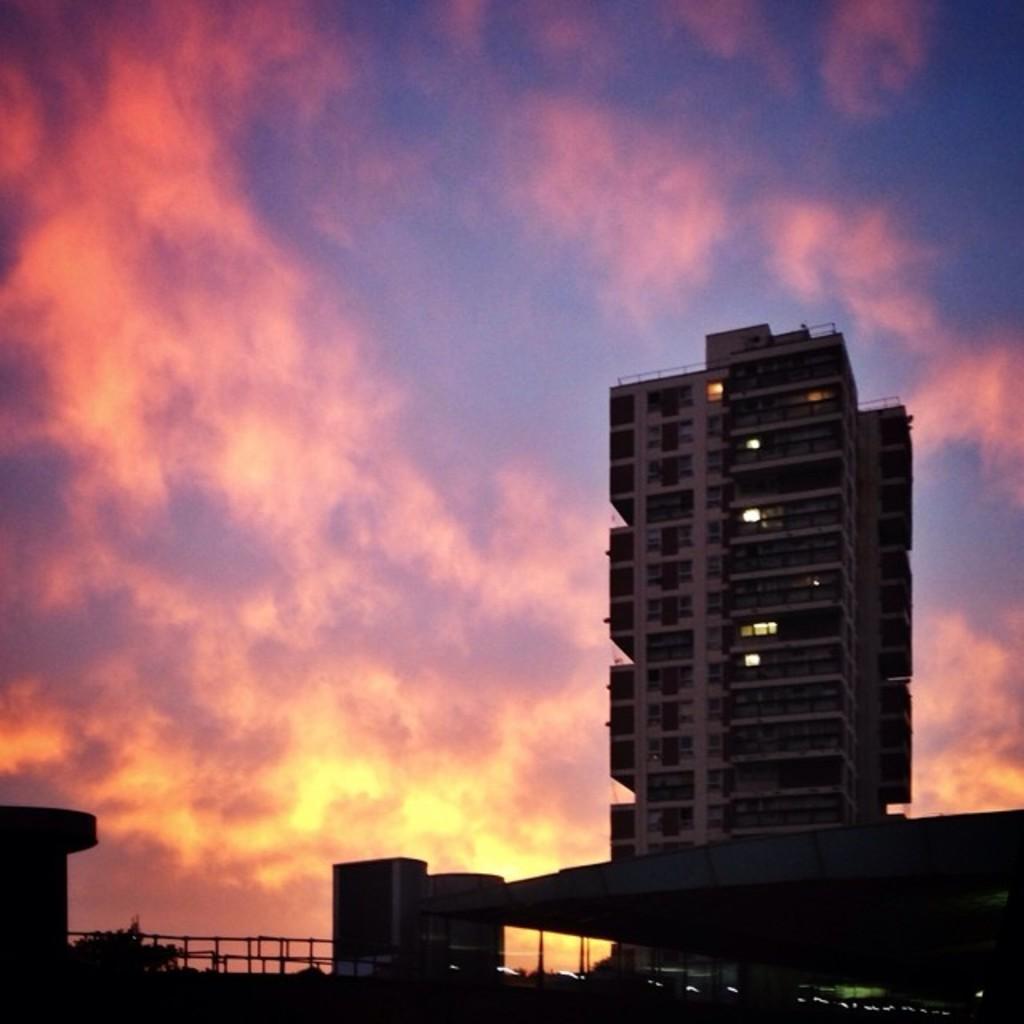In one or two sentences, can you explain what this image depicts? In this picture we can see buildings, here we can see a fence, tree and we can see sky in the background. 